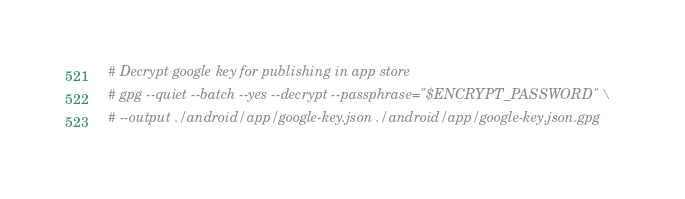<code> <loc_0><loc_0><loc_500><loc_500><_Bash_>

# Decrypt google key for publishing in app store
# gpg --quiet --batch --yes --decrypt --passphrase="$ENCRYPT_PASSWORD" \
# --output ./android/app/google-key.json ./android/app/google-key.json.gpg
</code> 